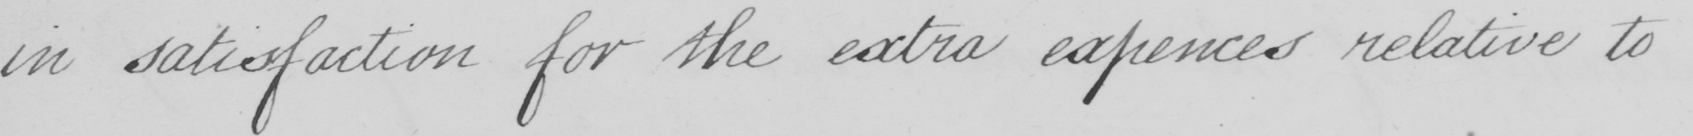Can you read and transcribe this handwriting? in satisfaction for the extra expences relative to 